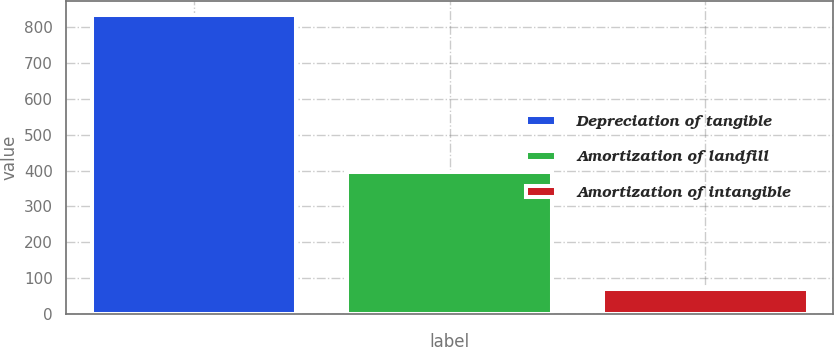<chart> <loc_0><loc_0><loc_500><loc_500><bar_chart><fcel>Depreciation of tangible<fcel>Amortization of landfill<fcel>Amortization of intangible<nl><fcel>833<fcel>395<fcel>69<nl></chart> 